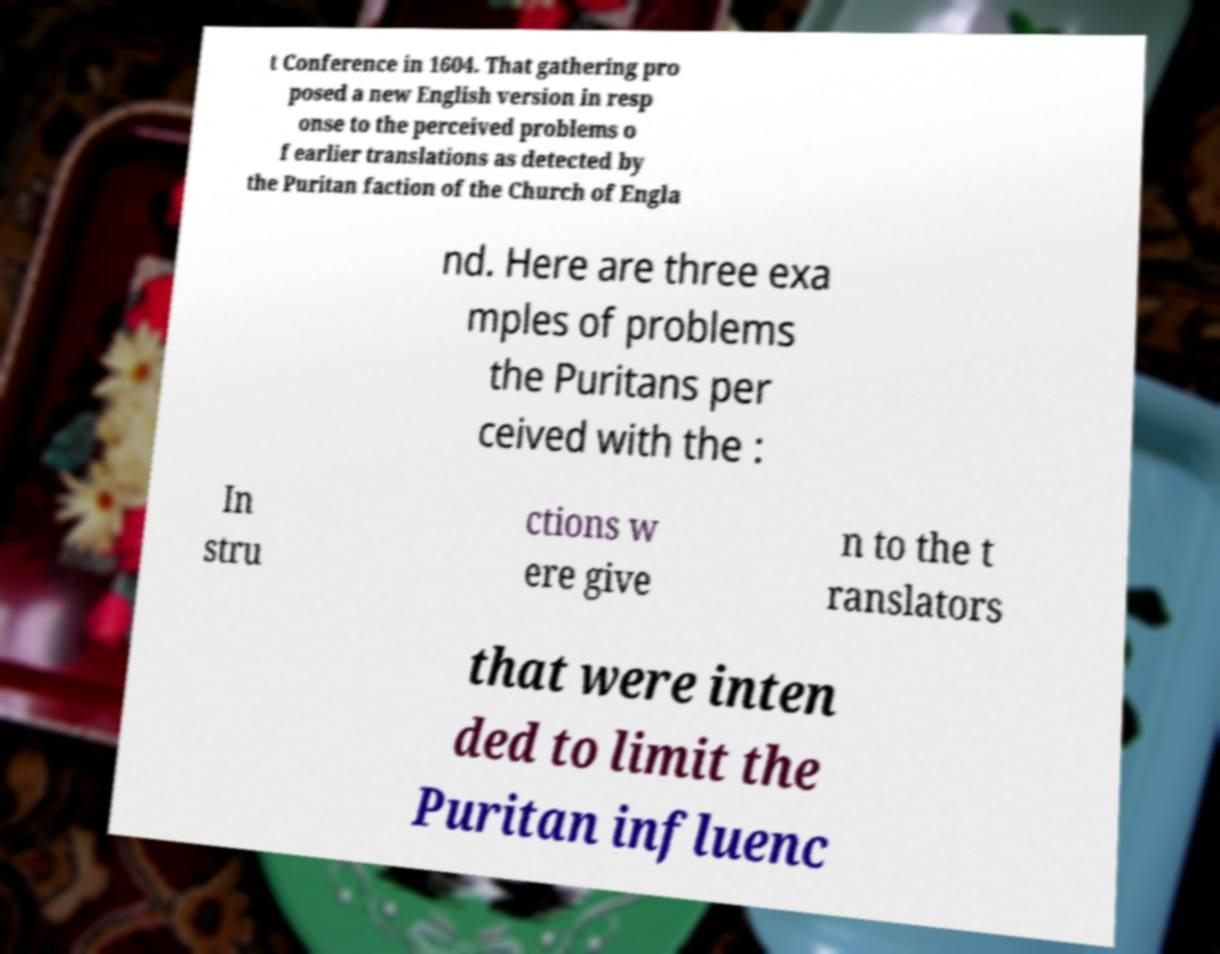Please read and relay the text visible in this image. What does it say? t Conference in 1604. That gathering pro posed a new English version in resp onse to the perceived problems o f earlier translations as detected by the Puritan faction of the Church of Engla nd. Here are three exa mples of problems the Puritans per ceived with the : In stru ctions w ere give n to the t ranslators that were inten ded to limit the Puritan influenc 